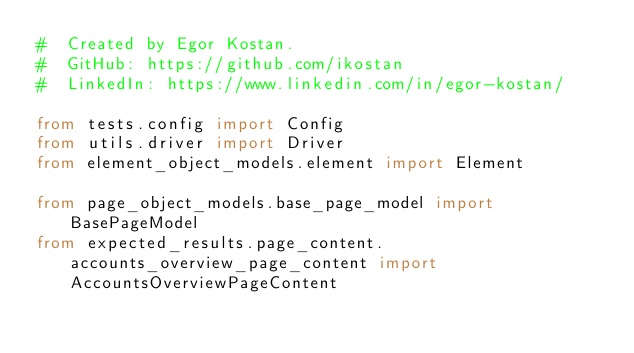Convert code to text. <code><loc_0><loc_0><loc_500><loc_500><_Python_>#  Created by Egor Kostan.
#  GitHub: https://github.com/ikostan
#  LinkedIn: https://www.linkedin.com/in/egor-kostan/

from tests.config import Config
from utils.driver import Driver
from element_object_models.element import Element

from page_object_models.base_page_model import BasePageModel
from expected_results.page_content.accounts_overview_page_content import AccountsOverviewPageContent</code> 